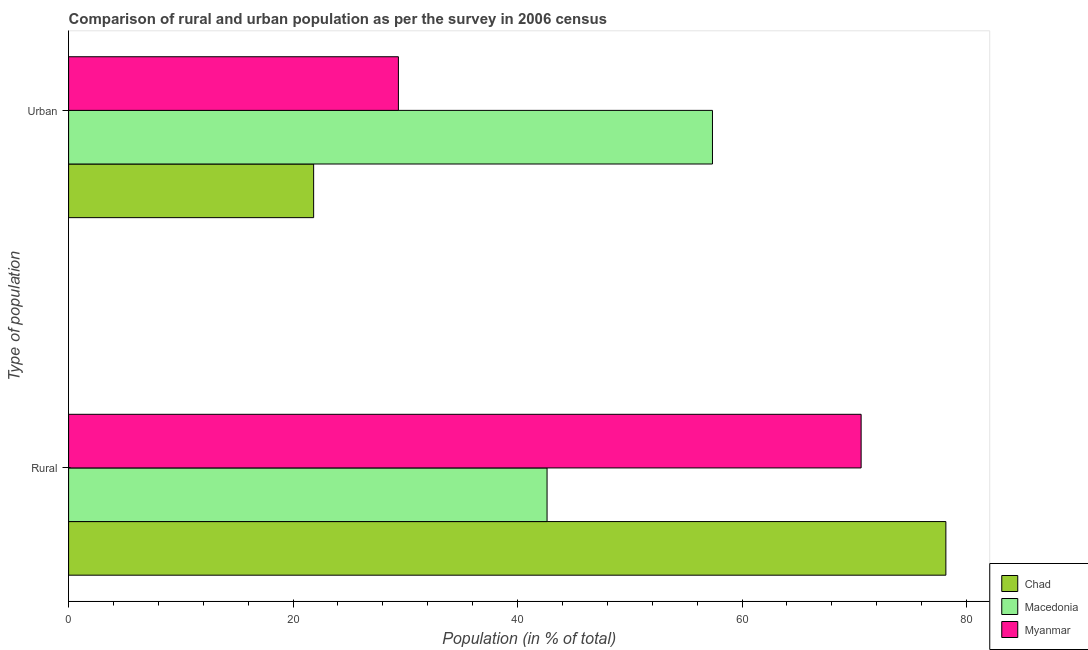Are the number of bars per tick equal to the number of legend labels?
Provide a succinct answer. Yes. Are the number of bars on each tick of the Y-axis equal?
Provide a succinct answer. Yes. How many bars are there on the 1st tick from the top?
Your response must be concise. 3. What is the label of the 2nd group of bars from the top?
Keep it short and to the point. Rural. What is the rural population in Macedonia?
Ensure brevity in your answer.  42.63. Across all countries, what is the maximum urban population?
Make the answer very short. 57.37. Across all countries, what is the minimum rural population?
Your answer should be very brief. 42.63. In which country was the urban population maximum?
Keep it short and to the point. Macedonia. In which country was the rural population minimum?
Provide a succinct answer. Macedonia. What is the total rural population in the graph?
Ensure brevity in your answer.  191.41. What is the difference between the rural population in Chad and that in Myanmar?
Give a very brief answer. 7.55. What is the difference between the rural population in Myanmar and the urban population in Macedonia?
Your response must be concise. 13.24. What is the average rural population per country?
Your response must be concise. 63.8. What is the difference between the rural population and urban population in Chad?
Your answer should be compact. 56.33. What is the ratio of the urban population in Chad to that in Macedonia?
Ensure brevity in your answer.  0.38. Is the rural population in Macedonia less than that in Chad?
Keep it short and to the point. Yes. In how many countries, is the rural population greater than the average rural population taken over all countries?
Give a very brief answer. 2. What does the 1st bar from the top in Urban represents?
Your answer should be very brief. Myanmar. What does the 3rd bar from the bottom in Rural represents?
Offer a terse response. Myanmar. How many bars are there?
Your answer should be compact. 6. How many countries are there in the graph?
Provide a short and direct response. 3. Are the values on the major ticks of X-axis written in scientific E-notation?
Provide a succinct answer. No. Does the graph contain any zero values?
Provide a short and direct response. No. Does the graph contain grids?
Your answer should be compact. No. How are the legend labels stacked?
Your response must be concise. Vertical. What is the title of the graph?
Your response must be concise. Comparison of rural and urban population as per the survey in 2006 census. What is the label or title of the X-axis?
Your answer should be compact. Population (in % of total). What is the label or title of the Y-axis?
Provide a succinct answer. Type of population. What is the Population (in % of total) in Chad in Rural?
Provide a succinct answer. 78.17. What is the Population (in % of total) of Macedonia in Rural?
Make the answer very short. 42.63. What is the Population (in % of total) of Myanmar in Rural?
Give a very brief answer. 70.61. What is the Population (in % of total) in Chad in Urban?
Your answer should be compact. 21.83. What is the Population (in % of total) of Macedonia in Urban?
Offer a very short reply. 57.37. What is the Population (in % of total) in Myanmar in Urban?
Ensure brevity in your answer.  29.39. Across all Type of population, what is the maximum Population (in % of total) of Chad?
Ensure brevity in your answer.  78.17. Across all Type of population, what is the maximum Population (in % of total) in Macedonia?
Offer a very short reply. 57.37. Across all Type of population, what is the maximum Population (in % of total) in Myanmar?
Make the answer very short. 70.61. Across all Type of population, what is the minimum Population (in % of total) in Chad?
Offer a terse response. 21.83. Across all Type of population, what is the minimum Population (in % of total) in Macedonia?
Your answer should be compact. 42.63. Across all Type of population, what is the minimum Population (in % of total) in Myanmar?
Provide a succinct answer. 29.39. What is the total Population (in % of total) of Chad in the graph?
Keep it short and to the point. 100. What is the total Population (in % of total) of Macedonia in the graph?
Keep it short and to the point. 100. What is the total Population (in % of total) in Myanmar in the graph?
Make the answer very short. 100. What is the difference between the Population (in % of total) in Chad in Rural and that in Urban?
Offer a very short reply. 56.33. What is the difference between the Population (in % of total) of Macedonia in Rural and that in Urban?
Offer a very short reply. -14.74. What is the difference between the Population (in % of total) in Myanmar in Rural and that in Urban?
Your response must be concise. 41.23. What is the difference between the Population (in % of total) of Chad in Rural and the Population (in % of total) of Macedonia in Urban?
Provide a short and direct response. 20.8. What is the difference between the Population (in % of total) of Chad in Rural and the Population (in % of total) of Myanmar in Urban?
Your response must be concise. 48.78. What is the difference between the Population (in % of total) in Macedonia in Rural and the Population (in % of total) in Myanmar in Urban?
Offer a very short reply. 13.24. What is the average Population (in % of total) of Chad per Type of population?
Give a very brief answer. 50. What is the average Population (in % of total) in Myanmar per Type of population?
Provide a succinct answer. 50. What is the difference between the Population (in % of total) of Chad and Population (in % of total) of Macedonia in Rural?
Provide a succinct answer. 35.53. What is the difference between the Population (in % of total) in Chad and Population (in % of total) in Myanmar in Rural?
Your response must be concise. 7.55. What is the difference between the Population (in % of total) of Macedonia and Population (in % of total) of Myanmar in Rural?
Provide a short and direct response. -27.98. What is the difference between the Population (in % of total) in Chad and Population (in % of total) in Macedonia in Urban?
Your response must be concise. -35.53. What is the difference between the Population (in % of total) of Chad and Population (in % of total) of Myanmar in Urban?
Your response must be concise. -7.55. What is the difference between the Population (in % of total) of Macedonia and Population (in % of total) of Myanmar in Urban?
Keep it short and to the point. 27.98. What is the ratio of the Population (in % of total) of Chad in Rural to that in Urban?
Your answer should be very brief. 3.58. What is the ratio of the Population (in % of total) in Macedonia in Rural to that in Urban?
Offer a terse response. 0.74. What is the ratio of the Population (in % of total) in Myanmar in Rural to that in Urban?
Provide a succinct answer. 2.4. What is the difference between the highest and the second highest Population (in % of total) in Chad?
Keep it short and to the point. 56.33. What is the difference between the highest and the second highest Population (in % of total) in Macedonia?
Your answer should be compact. 14.74. What is the difference between the highest and the second highest Population (in % of total) of Myanmar?
Provide a short and direct response. 41.23. What is the difference between the highest and the lowest Population (in % of total) of Chad?
Ensure brevity in your answer.  56.33. What is the difference between the highest and the lowest Population (in % of total) in Macedonia?
Give a very brief answer. 14.74. What is the difference between the highest and the lowest Population (in % of total) in Myanmar?
Your response must be concise. 41.23. 